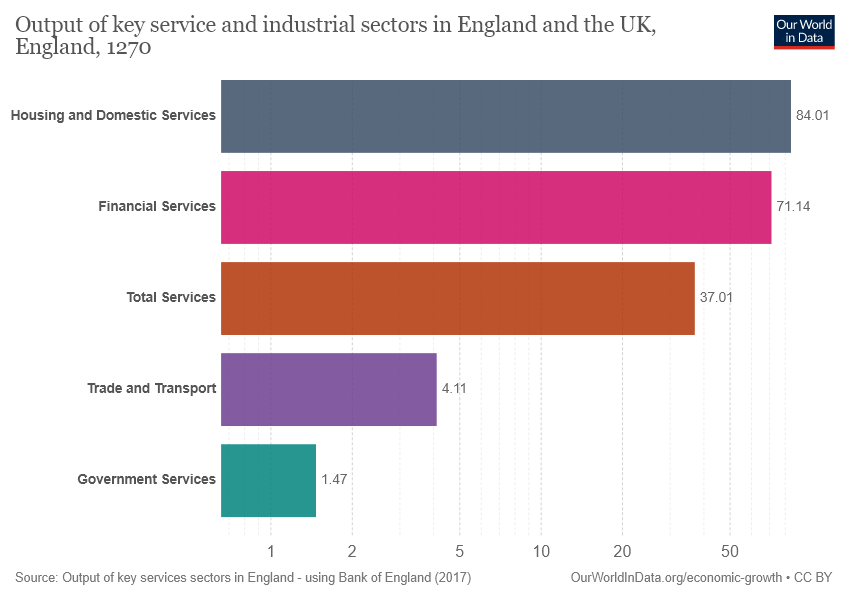Draw attention to some important aspects in this diagram. The value for trade and transport is 4.11. Financial services are significantly larger than trade and transport in terms of their overall size and impact. Specifically, the financial services sector is estimated to be approximately 17.31 times larger than the trade and transport sector. 